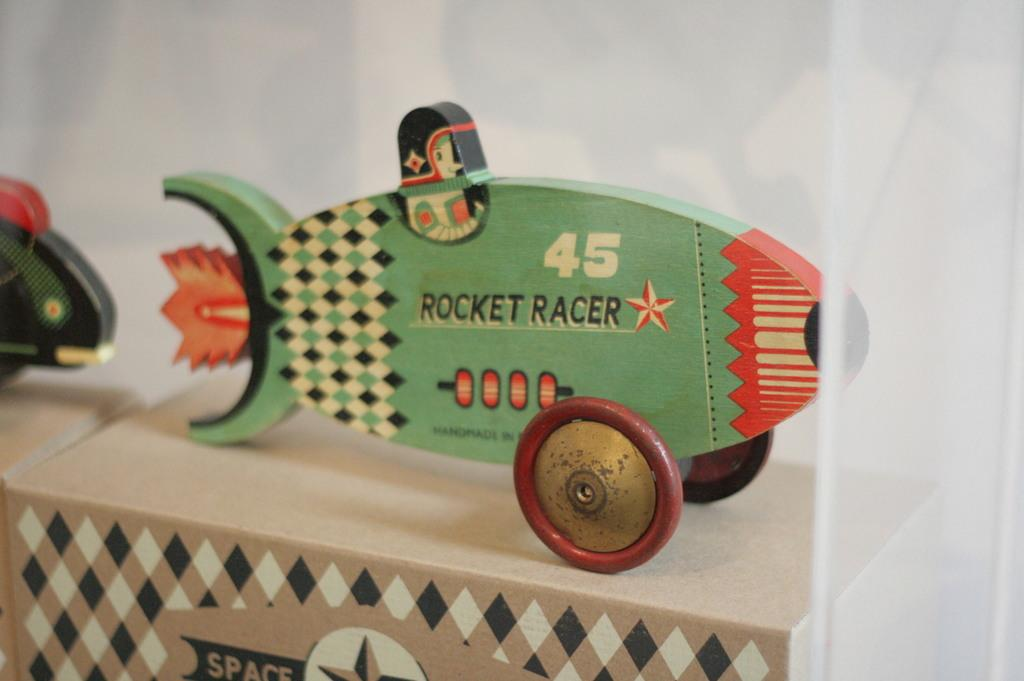What type of toy is in the image? There is a toy rocket in the image. What is written on the toy rocket? The toy rocket has the words "rocket racer" written on it. How many wheels does the toy rocket have? The toy rocket has 2 wheels. How many letters are in the request for a pail in the image? There is no request for a pail in the image, and therefore no letters associated with it. 